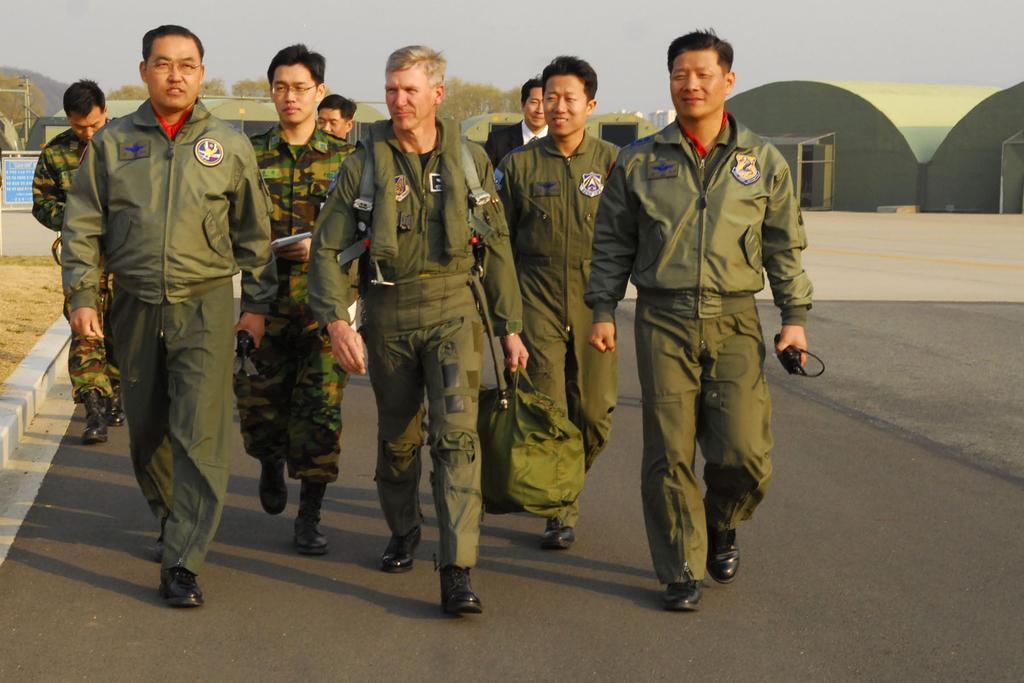Can you describe this image briefly? In this picture we can see group of people, they are walking on the road, behind to them we can see few buildings, trees, pole and a board. 